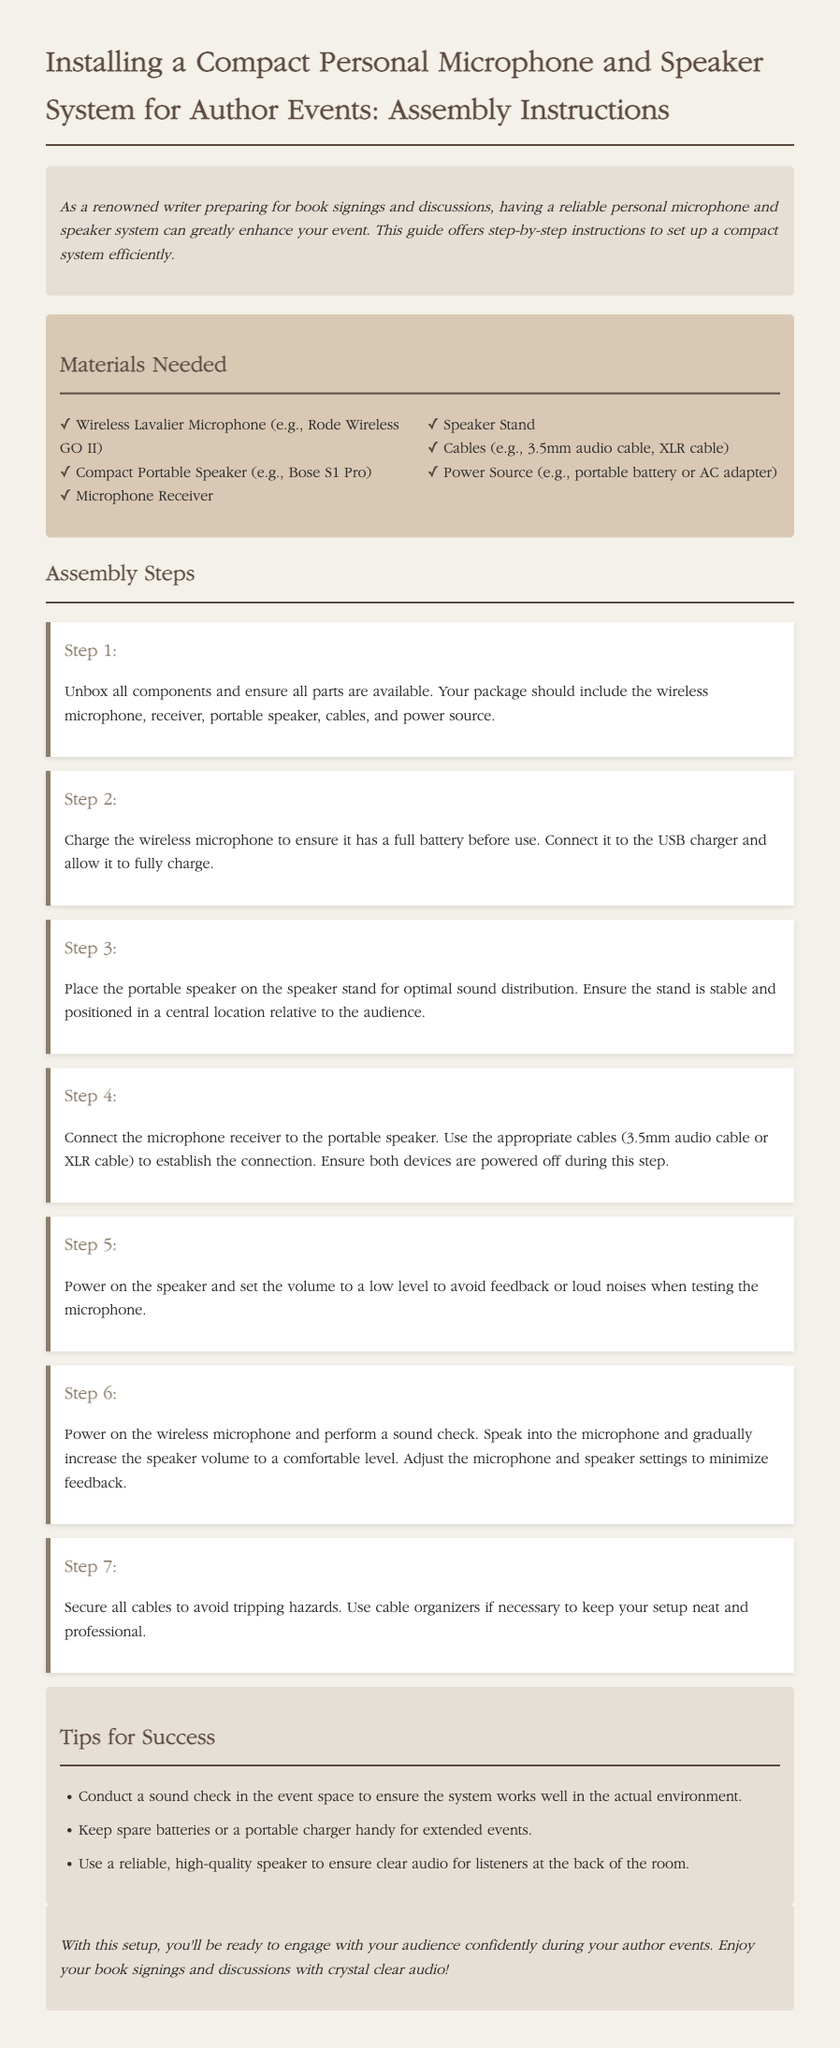What is the title of the document? The title is found at the beginning of the document, stating the focus on installing a compact personal microphone and speaker system for author events.
Answer: Installing a Compact Personal Microphone and Speaker System for Author Events: Assembly Instructions How many steps are there in the assembly instructions? The total number of steps is mentioned under the assembly steps heading, where each step is clearly numbered.
Answer: 7 What type of microphone is recommended in the materials needed? The specific type of microphone required is listed in the materials section of the document.
Answer: Wireless Lavalier Microphone What should be done before using the wireless microphone? The instructions specify a necessary action to perform regarding the wireless microphone prior to use.
Answer: Charge the wireless microphone What is the purpose of power on the speaker before testing? The document mentions the reason for powering on the speaker before testing the microphone volume to avoid issues.
Answer: To avoid feedback or loud noises What should be used to secure the cables? A specific item is suggested in the assembly instructions to ensure that cables are organized and secure.
Answer: Cable organizers Why is it important to conduct a sound check? The reasoning behind conducting a sound check is explained in the tips section for ensuring optimal setup during events.
Answer: To ensure the system works well in the actual environment 